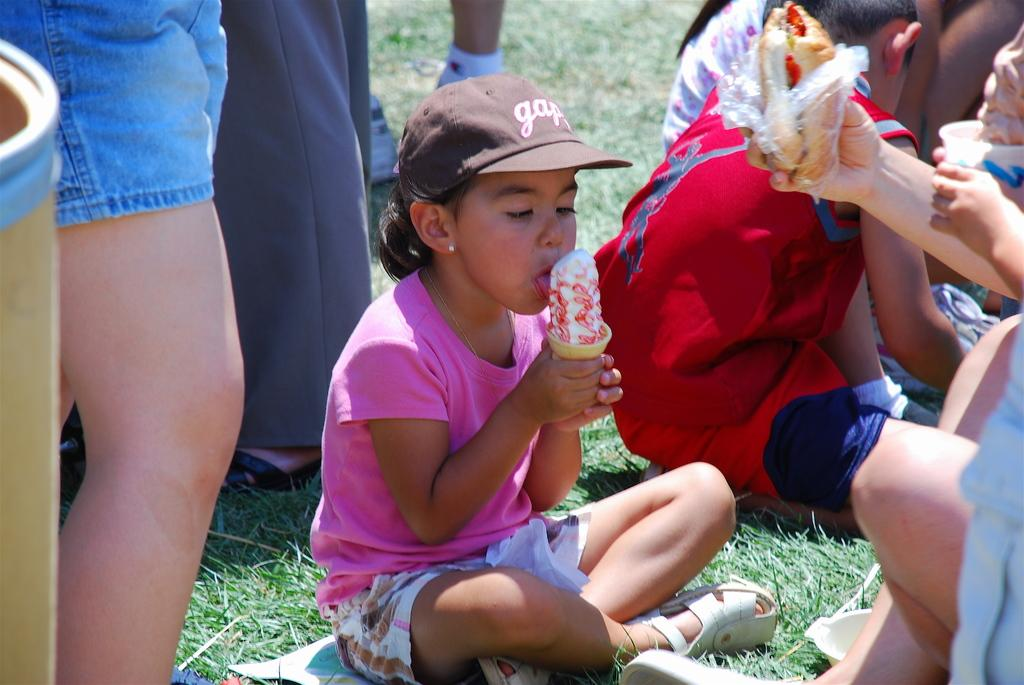<image>
Create a compact narrative representing the image presented. A girl wearing a gap hat is eating ice cream outside. 